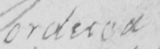What is written in this line of handwriting? ordered 